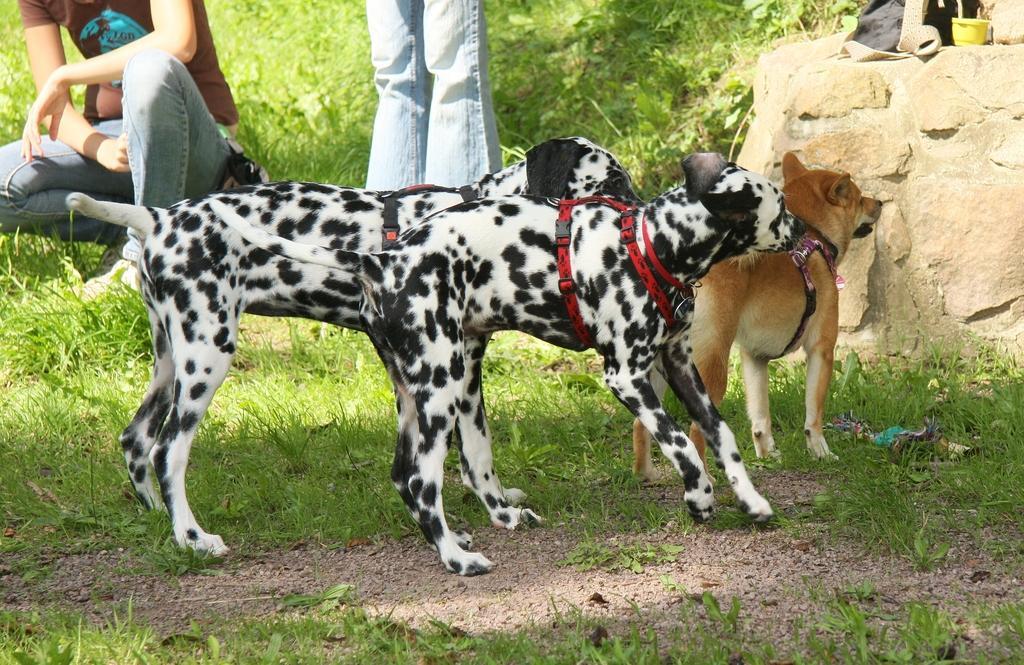Describe this image in one or two sentences. In this image we can see two black and white color dog and one brown dog is standing on the grassy surface. Background rock and two persons are there. On rock one bag is present. 